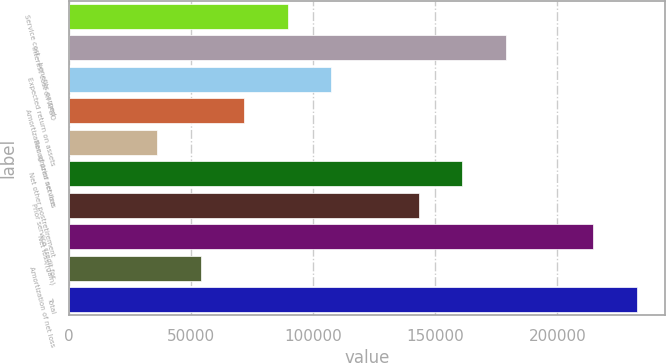Convert chart. <chart><loc_0><loc_0><loc_500><loc_500><bar_chart><fcel>Service cost - benefits earned<fcel>Interest cost on APBO<fcel>Expected return on assets<fcel>Amortization of prior service<fcel>Recognized net loss<fcel>Net other postretirement<fcel>Prior service credit for<fcel>Net loss/(gain)<fcel>Amortization of net loss<fcel>Total<nl><fcel>89658<fcel>178963<fcel>107519<fcel>71797<fcel>36075<fcel>161102<fcel>143241<fcel>214685<fcel>53936<fcel>232546<nl></chart> 